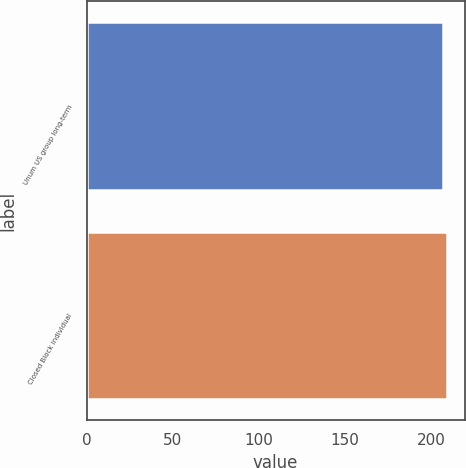<chart> <loc_0><loc_0><loc_500><loc_500><bar_chart><fcel>Unum US group long-term<fcel>Closed Block individual<nl><fcel>207<fcel>209<nl></chart> 